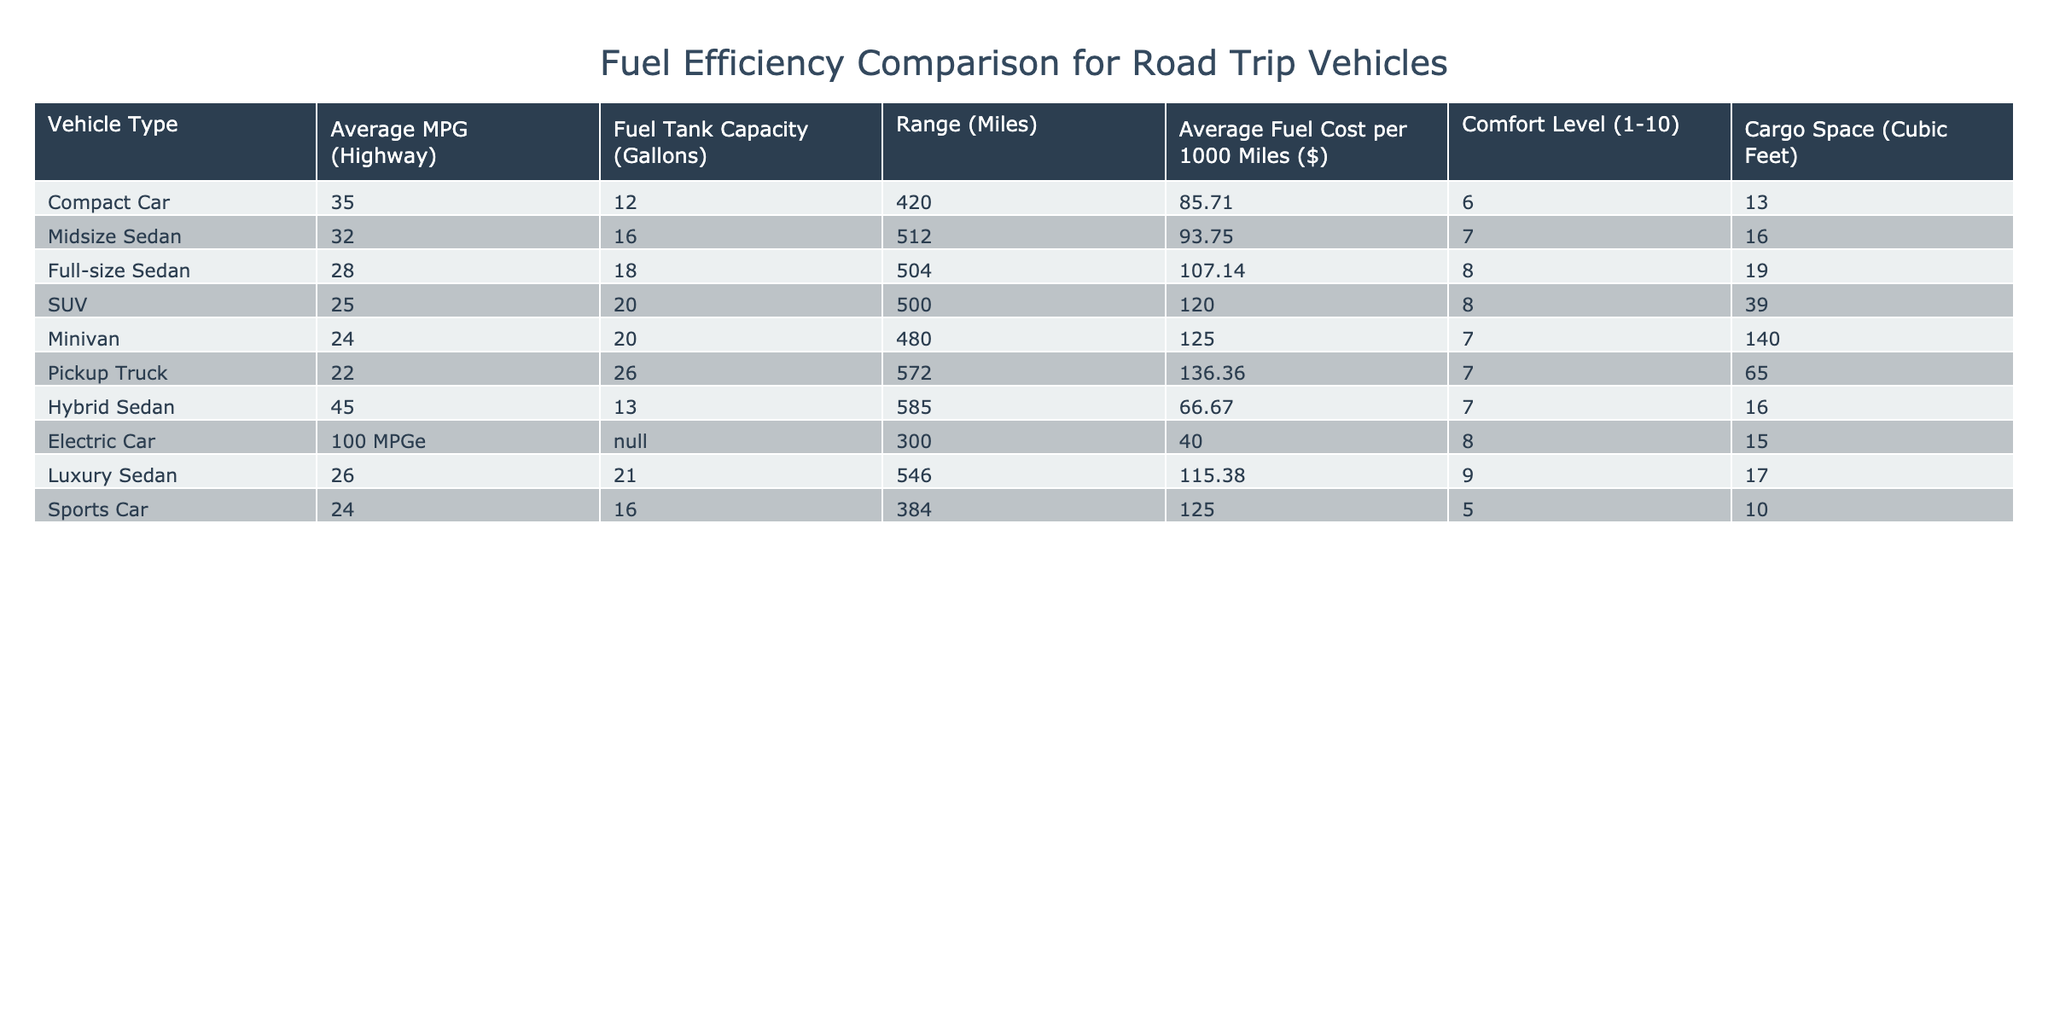What is the average MPG for SUVs? The table shows that the average MPG for SUVs is 25, which can be found directly in the "Average MPG (Highway)" column for the SUV row.
Answer: 25 Which vehicle type has the largest cargo space? By looking at the "Cargo Space (Cubic Feet)" column, the Minivan has the largest cargo space at 140 cubic feet, which is greater than all other vehicle types listed.
Answer: Minivan How much more expensive per 1000 miles is the fuel cost for a Pickup Truck compared to a Hybrid Sedan? The Pickup Truck has a fuel cost of 136.36 dollars per 1000 miles while the Hybrid Sedan has a cost of 66.67 dollars. The difference is calculated as 136.36 - 66.67 = 69.69 dollars.
Answer: 69.69 Which vehicle type offers the highest comfort level? The comfort level is indicated in the "Comfort Level (1-10)" column. The Luxury Sedan has the highest comfort level at 9, which is greater than the comfort levels of all other vehicle types.
Answer: Luxury Sedan Is it true that Electric Cars have the highest fuel efficiency compared to others? Yes, Electric Cars have a fuel efficiency of 100 MPGe, which is higher than the MPG values of all other vehicle types listed in the table.
Answer: Yes What is the average range of Midsize Sedans and Full-size Sedans combined? The average range for Midsize Sedans is 512 miles and for Full-size Sedans is 504 miles. The sum of their ranges is 512 + 504 = 1016 miles and the average is 1016 / 2 = 508 miles.
Answer: 508 What is the difference in fuel tank capacity between the Compact Car and the SUV? The Compact Car has a fuel tank capacity of 12 gallons, and the SUV has 20 gallons. The difference in capacity is 20 - 12 = 8 gallons.
Answer: 8 Which vehicle type has the lowest comfort level? The "Comfort Level (1-10)" column shows the Sports Car with a comfort level of 5, which is lower than that of all other vehicle types listed.
Answer: Sports Car What is the total range of all vehicle types that have a fuel tank capacity of 20 gallons or more? The vehicles with 20 gallons or more are the SUV, Minivan, and Pickup Truck. Their ranges are 500, 480, and 572 miles respectively. The total range is 500 + 480 + 572 = 1552 miles.
Answer: 1552 